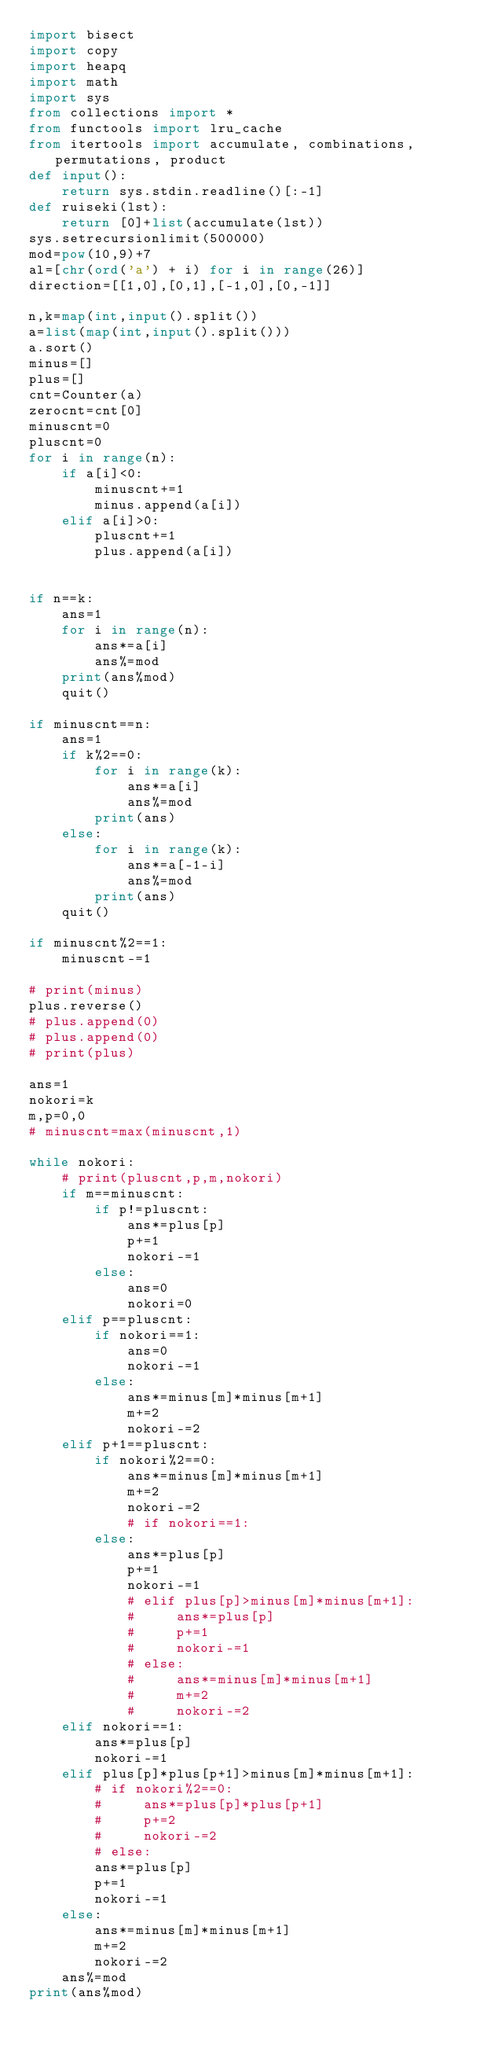<code> <loc_0><loc_0><loc_500><loc_500><_Python_>import bisect
import copy
import heapq
import math
import sys
from collections import *
from functools import lru_cache
from itertools import accumulate, combinations, permutations, product
def input():
    return sys.stdin.readline()[:-1]
def ruiseki(lst):
    return [0]+list(accumulate(lst))
sys.setrecursionlimit(500000)
mod=pow(10,9)+7
al=[chr(ord('a') + i) for i in range(26)]
direction=[[1,0],[0,1],[-1,0],[0,-1]]

n,k=map(int,input().split())
a=list(map(int,input().split()))
a.sort()
minus=[]
plus=[]
cnt=Counter(a)
zerocnt=cnt[0]
minuscnt=0
pluscnt=0
for i in range(n):
    if a[i]<0:
        minuscnt+=1
        minus.append(a[i])
    elif a[i]>0:
        pluscnt+=1
        plus.append(a[i])


if n==k:
    ans=1
    for i in range(n):
        ans*=a[i]
        ans%=mod
    print(ans%mod)
    quit()

if minuscnt==n:
    ans=1
    if k%2==0:
        for i in range(k):
            ans*=a[i]
            ans%=mod
        print(ans)
    else:
        for i in range(k):
            ans*=a[-1-i]
            ans%=mod
        print(ans)
    quit()

if minuscnt%2==1:
    minuscnt-=1

# print(minus)
plus.reverse()
# plus.append(0)
# plus.append(0)
# print(plus)

ans=1
nokori=k
m,p=0,0
# minuscnt=max(minuscnt,1)

while nokori:
    # print(pluscnt,p,m,nokori)
    if m==minuscnt:
        if p!=pluscnt:
            ans*=plus[p]
            p+=1
            nokori-=1
        else:
            ans=0
            nokori=0
    elif p==pluscnt:
        if nokori==1:
            ans=0
            nokori-=1
        else:
            ans*=minus[m]*minus[m+1]
            m+=2
            nokori-=2
    elif p+1==pluscnt:
        if nokori%2==0:
            ans*=minus[m]*minus[m+1]
            m+=2
            nokori-=2
            # if nokori==1:
        else:
            ans*=plus[p]
            p+=1
            nokori-=1
            # elif plus[p]>minus[m]*minus[m+1]:
            #     ans*=plus[p]
            #     p+=1
            #     nokori-=1
            # else:
            #     ans*=minus[m]*minus[m+1]
            #     m+=2
            #     nokori-=2
    elif nokori==1:
        ans*=plus[p]
        nokori-=1
    elif plus[p]*plus[p+1]>minus[m]*minus[m+1]:
        # if nokori%2==0:
        #     ans*=plus[p]*plus[p+1]
        #     p+=2
        #     nokori-=2
        # else:
        ans*=plus[p]
        p+=1
        nokori-=1
    else:
        ans*=minus[m]*minus[m+1]
        m+=2
        nokori-=2
    ans%=mod
print(ans%mod)</code> 